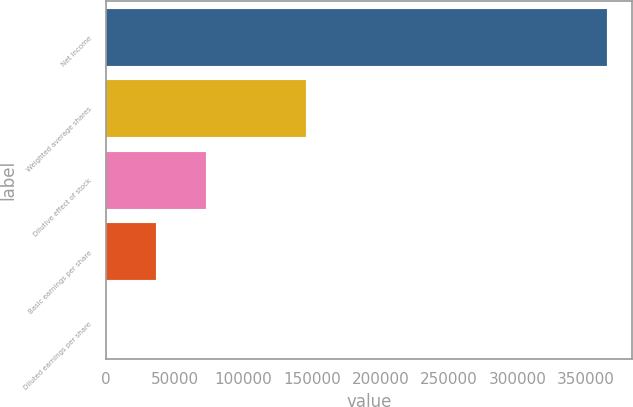Convert chart to OTSL. <chart><loc_0><loc_0><loc_500><loc_500><bar_chart><fcel>Net Income<fcel>Weighted average shares<fcel>Dilutive effect of stock<fcel>Basic earnings per share<fcel>Diluted earnings per share<nl><fcel>365034<fcel>146016<fcel>73010.6<fcel>36507.6<fcel>4.7<nl></chart> 